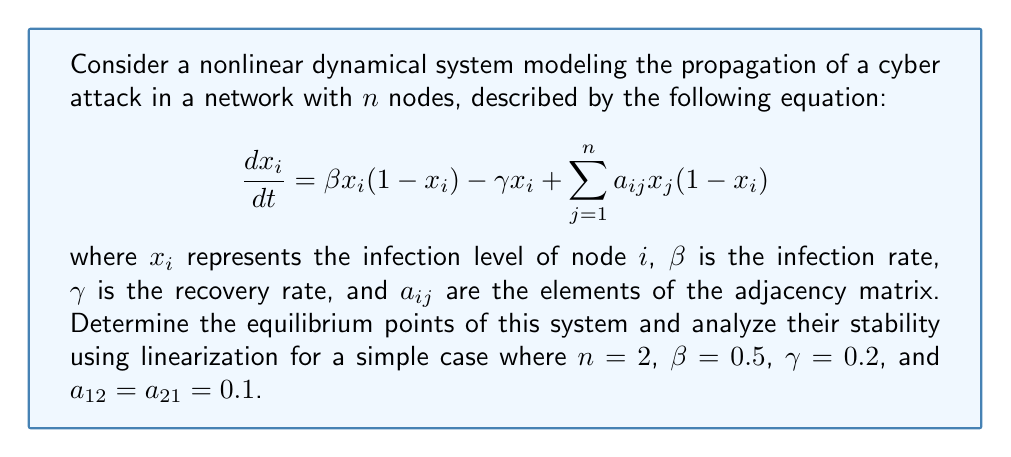Provide a solution to this math problem. To solve this problem, we'll follow these steps:

1) Find the equilibrium points by setting $\frac{dx_i}{dt} = 0$ for all $i$.
2) Linearize the system around each equilibrium point.
3) Analyze the stability of each equilibrium point using the eigenvalues of the Jacobian matrix.

Step 1: Finding equilibrium points

For $n=2$, we have two equations:

$$\frac{dx_1}{dt} = 0.5x_1(1-x_1) - 0.2x_1 + 0.1x_2(1-x_1)$$
$$\frac{dx_2}{dt} = 0.5x_2(1-x_2) - 0.2x_2 + 0.1x_1(1-x_2)$$

Setting both equations to zero and solving, we find three equilibrium points:
$(0,0)$, $(1,1)$, and $(0.6,0.6)$

Step 2: Linearization

The Jacobian matrix for this system is:

$$J = \begin{bmatrix}
0.5-x_1-0.2-0.1x_2 & 0.1(1-x_1) \\
0.1(1-x_2) & 0.5-x_2-0.2-0.1x_1
\end{bmatrix}$$

Step 3: Stability analysis

For $(0,0)$:
$$J_{(0,0)} = \begin{bmatrix}
0.3 & 0.1 \\
0.1 & 0.3
\end{bmatrix}$$

Eigenvalues: $\lambda_1 = 0.4$, $\lambda_2 = 0.2$
Both positive, so $(0,0)$ is unstable.

For $(1,1)$:
$$J_{(1,1)} = \begin{bmatrix}
-0.8 & 0 \\
0 & -0.8
\end{bmatrix}$$

Eigenvalues: $\lambda_1 = \lambda_2 = -0.8$
Both negative, so $(1,1)$ is stable.

For $(0.6,0.6)$:
$$J_{(0.6,0.6)} = \begin{bmatrix}
-0.26 & 0.04 \\
0.04 & -0.26
\end{bmatrix}$$

Eigenvalues: $\lambda_1 = -0.3$, $\lambda_2 = -0.22$
Both negative, so $(0.6,0.6)$ is stable.
Answer: $(0,0)$ unstable; $(1,1)$ and $(0.6,0.6)$ stable 